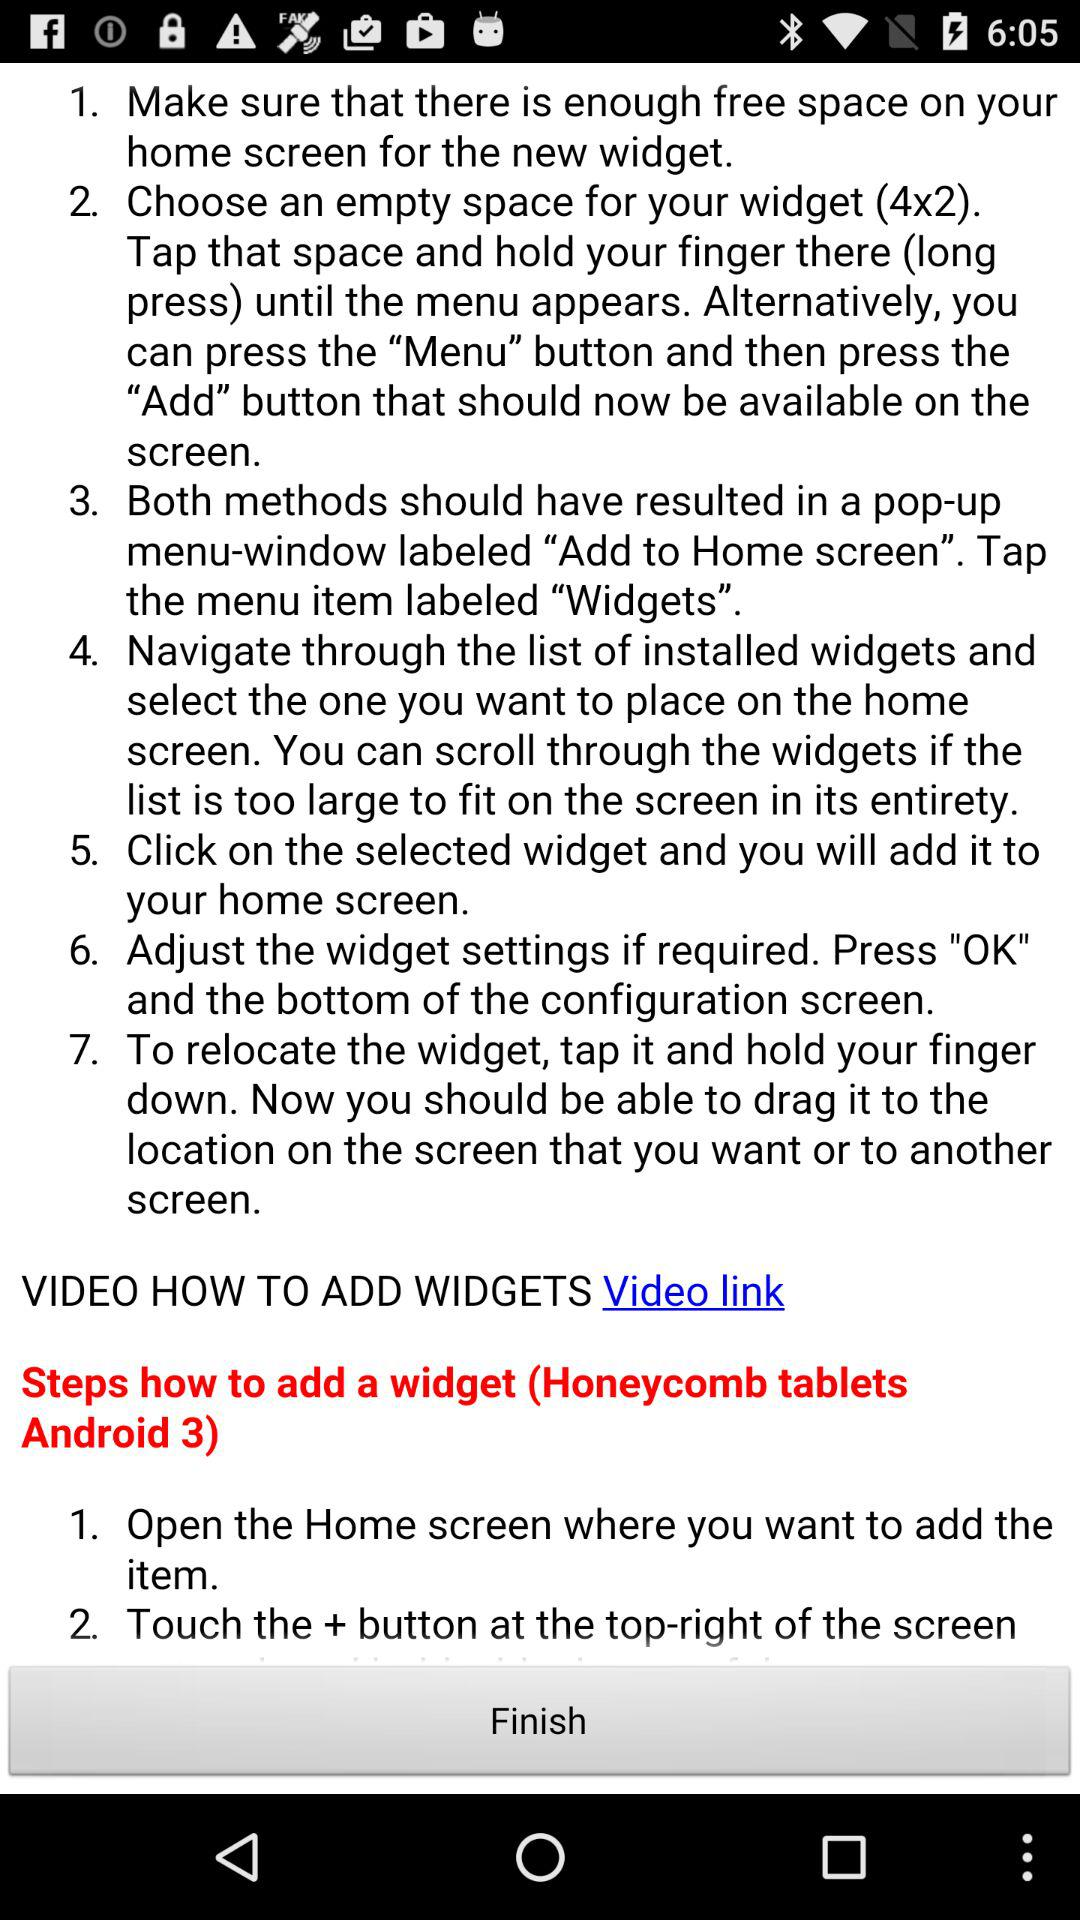What are the steps to add a widget? The step to add a widget is "Open the Home screen where you want to add the item". 